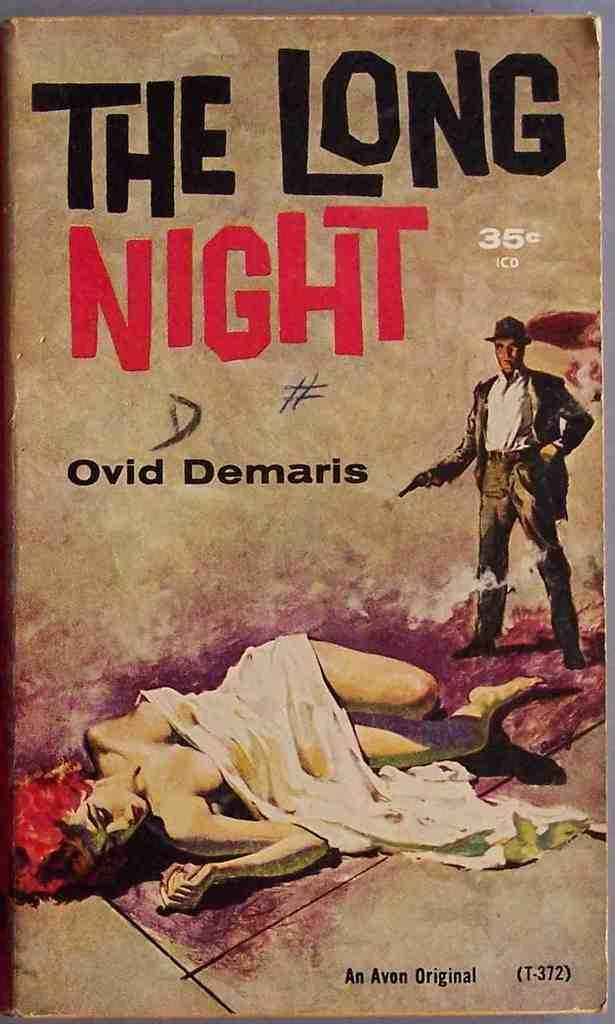<image>
Describe the image concisely. The Long Night has a price of 35 cents. 